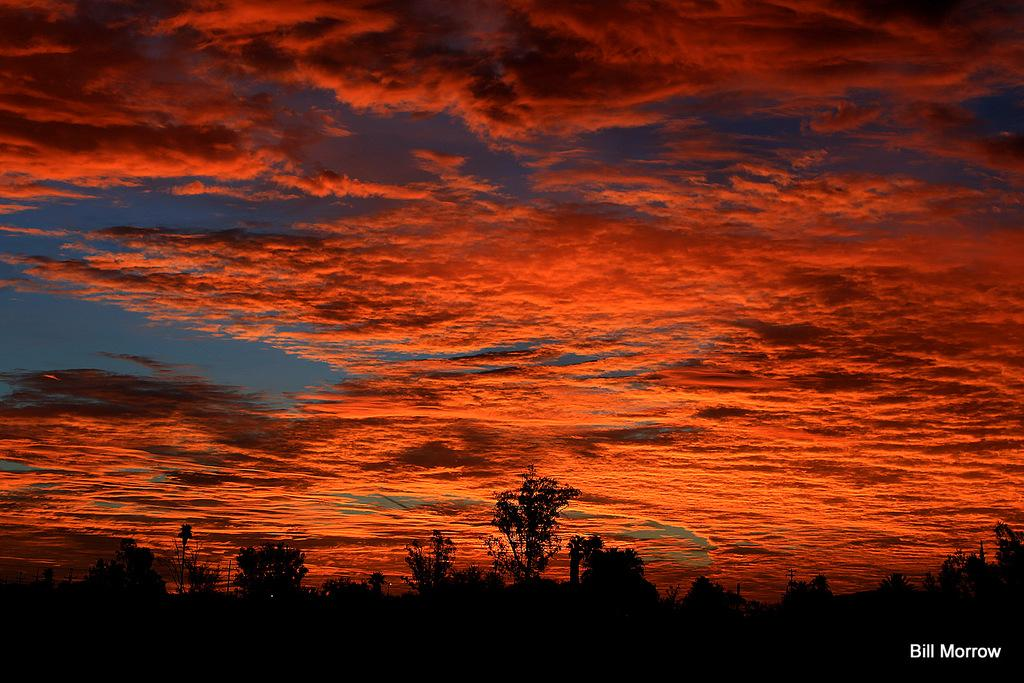What type of vegetation can be seen in the image? There are trees in the image. What is the color of the clouds in the image? The clouds in the image are orange in color. How would you describe the lighting in the image? The image appears to be a bit dark. Is there any text or logo visible in the image? Yes, there is a watermark in the image. Can you see a cherry hanging from the trees in the image? There are no cherries visible in the image; only trees are present. Is there a table in the image? There is no table present in the image. 